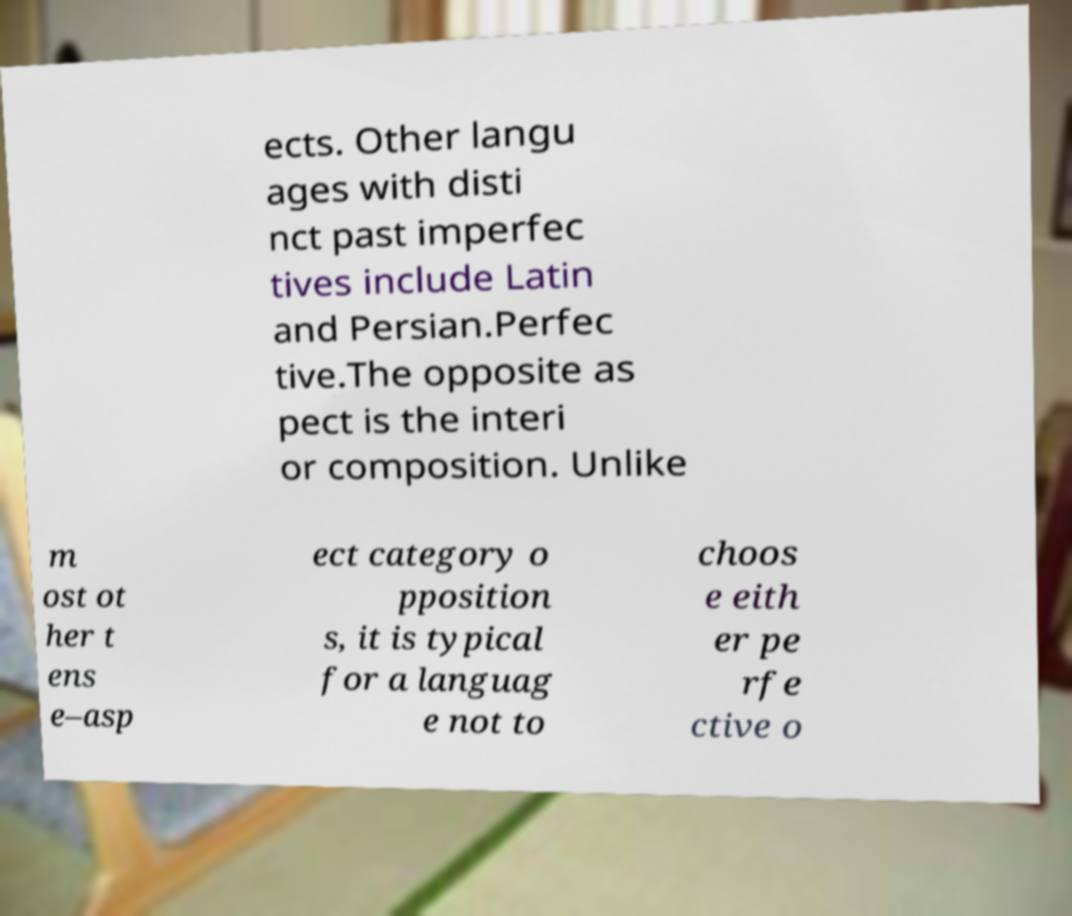Can you read and provide the text displayed in the image?This photo seems to have some interesting text. Can you extract and type it out for me? ects. Other langu ages with disti nct past imperfec tives include Latin and Persian.Perfec tive.The opposite as pect is the interi or composition. Unlike m ost ot her t ens e–asp ect category o pposition s, it is typical for a languag e not to choos e eith er pe rfe ctive o 